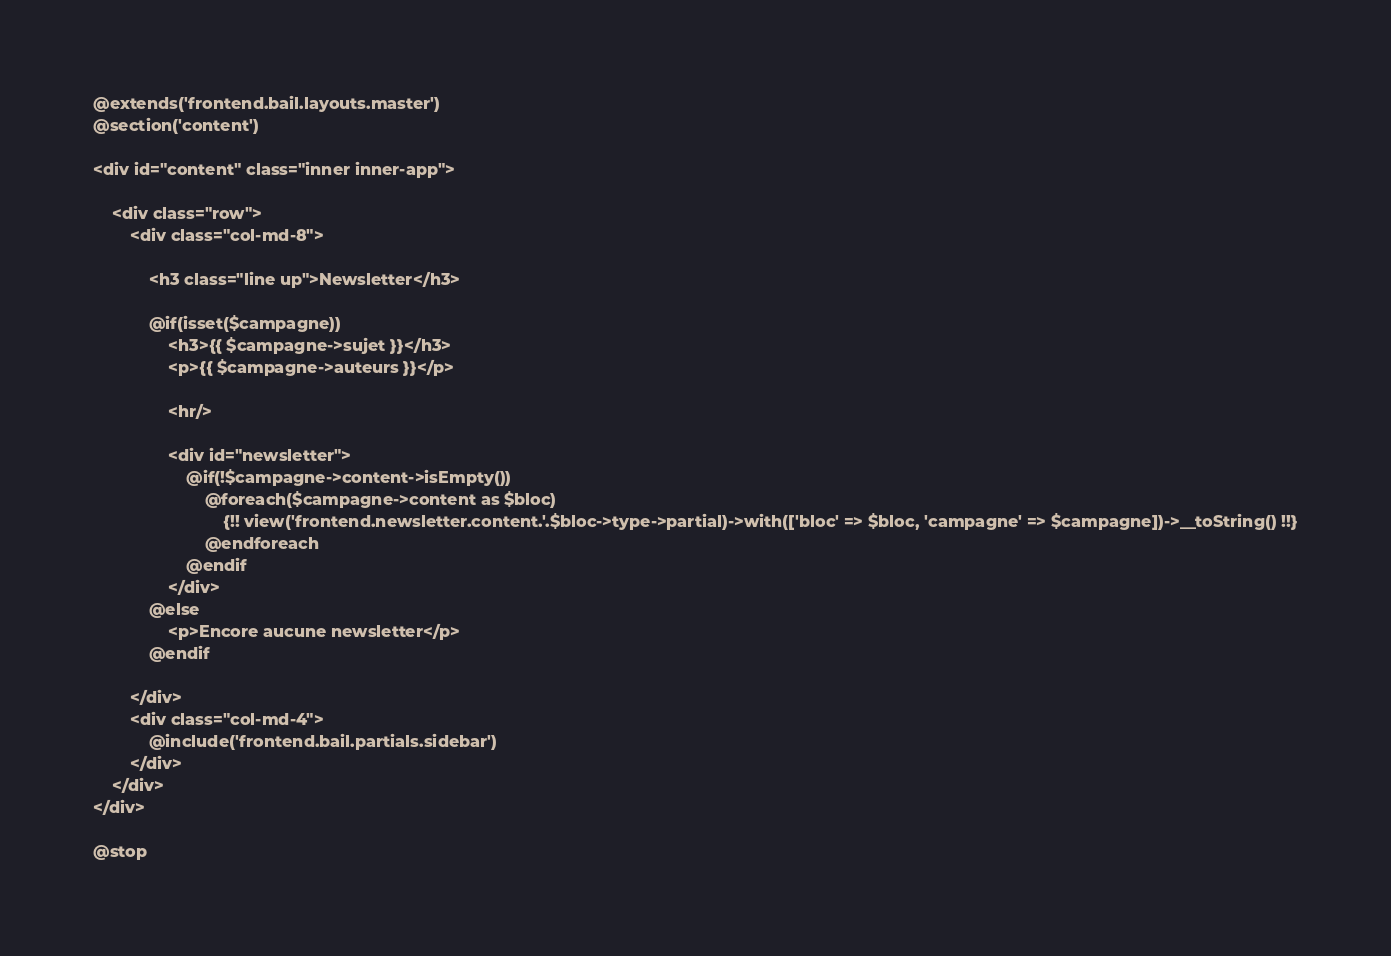Convert code to text. <code><loc_0><loc_0><loc_500><loc_500><_PHP_>@extends('frontend.bail.layouts.master')
@section('content')

<div id="content" class="inner inner-app">

	<div class="row">
		<div class="col-md-8">

			<h3 class="line up">Newsletter</h3>

			@if(isset($campagne))
				<h3>{{ $campagne->sujet }}</h3>
				<p>{{ $campagne->auteurs }}</p>

				<hr/>

				<div id="newsletter">
					@if(!$campagne->content->isEmpty())
						@foreach($campagne->content as $bloc)
							{!! view('frontend.newsletter.content.'.$bloc->type->partial)->with(['bloc' => $bloc, 'campagne' => $campagne])->__toString() !!}
						@endforeach
					@endif
				</div>
			@else
				<p>Encore aucune newsletter</p>
			@endif

		</div>
		<div class="col-md-4">
			@include('frontend.bail.partials.sidebar')
		</div>
	</div>
</div>

@stop
</code> 